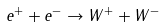<formula> <loc_0><loc_0><loc_500><loc_500>e ^ { + } + e ^ { - } \to W ^ { + } + W ^ { - }</formula> 